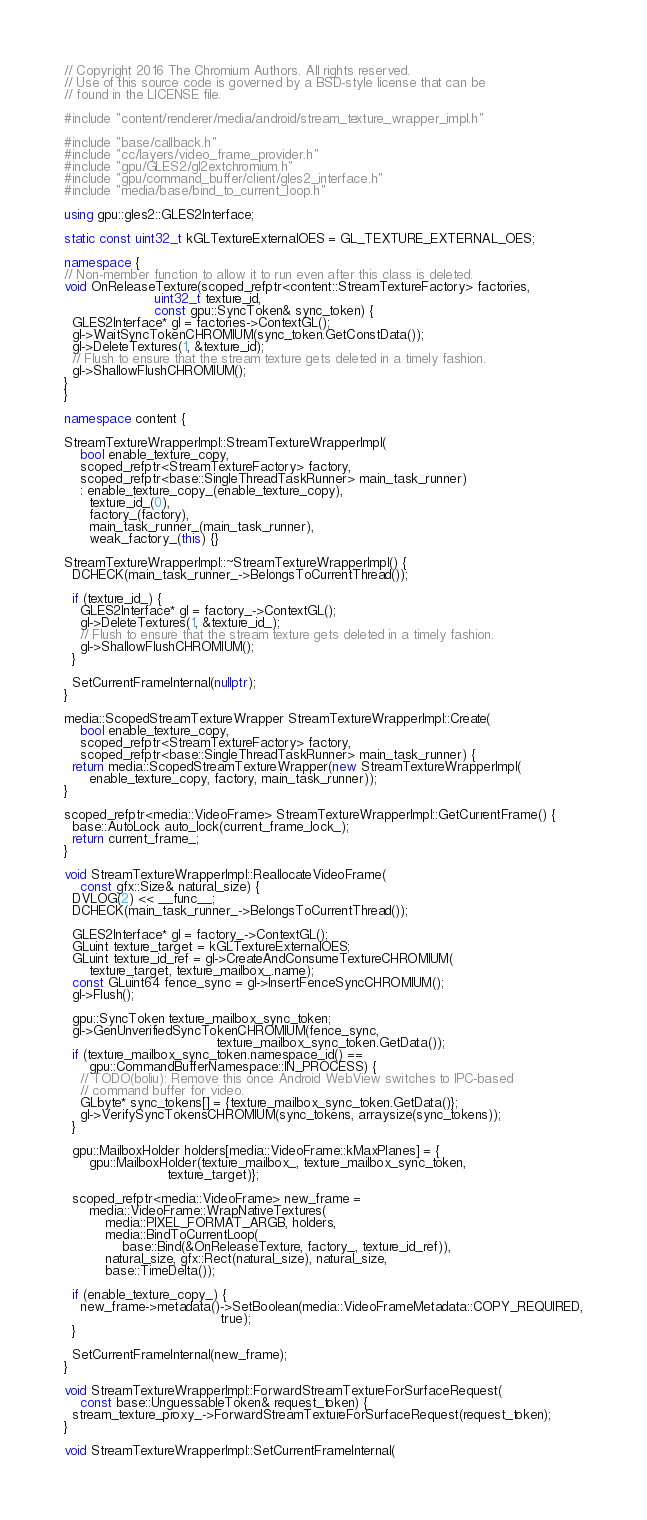Convert code to text. <code><loc_0><loc_0><loc_500><loc_500><_C++_>// Copyright 2016 The Chromium Authors. All rights reserved.
// Use of this source code is governed by a BSD-style license that can be
// found in the LICENSE file.

#include "content/renderer/media/android/stream_texture_wrapper_impl.h"

#include "base/callback.h"
#include "cc/layers/video_frame_provider.h"
#include "gpu/GLES2/gl2extchromium.h"
#include "gpu/command_buffer/client/gles2_interface.h"
#include "media/base/bind_to_current_loop.h"

using gpu::gles2::GLES2Interface;

static const uint32_t kGLTextureExternalOES = GL_TEXTURE_EXTERNAL_OES;

namespace {
// Non-member function to allow it to run even after this class is deleted.
void OnReleaseTexture(scoped_refptr<content::StreamTextureFactory> factories,
                      uint32_t texture_id,
                      const gpu::SyncToken& sync_token) {
  GLES2Interface* gl = factories->ContextGL();
  gl->WaitSyncTokenCHROMIUM(sync_token.GetConstData());
  gl->DeleteTextures(1, &texture_id);
  // Flush to ensure that the stream texture gets deleted in a timely fashion.
  gl->ShallowFlushCHROMIUM();
}
}

namespace content {

StreamTextureWrapperImpl::StreamTextureWrapperImpl(
    bool enable_texture_copy,
    scoped_refptr<StreamTextureFactory> factory,
    scoped_refptr<base::SingleThreadTaskRunner> main_task_runner)
    : enable_texture_copy_(enable_texture_copy),
      texture_id_(0),
      factory_(factory),
      main_task_runner_(main_task_runner),
      weak_factory_(this) {}

StreamTextureWrapperImpl::~StreamTextureWrapperImpl() {
  DCHECK(main_task_runner_->BelongsToCurrentThread());

  if (texture_id_) {
    GLES2Interface* gl = factory_->ContextGL();
    gl->DeleteTextures(1, &texture_id_);
    // Flush to ensure that the stream texture gets deleted in a timely fashion.
    gl->ShallowFlushCHROMIUM();
  }

  SetCurrentFrameInternal(nullptr);
}

media::ScopedStreamTextureWrapper StreamTextureWrapperImpl::Create(
    bool enable_texture_copy,
    scoped_refptr<StreamTextureFactory> factory,
    scoped_refptr<base::SingleThreadTaskRunner> main_task_runner) {
  return media::ScopedStreamTextureWrapper(new StreamTextureWrapperImpl(
      enable_texture_copy, factory, main_task_runner));
}

scoped_refptr<media::VideoFrame> StreamTextureWrapperImpl::GetCurrentFrame() {
  base::AutoLock auto_lock(current_frame_lock_);
  return current_frame_;
}

void StreamTextureWrapperImpl::ReallocateVideoFrame(
    const gfx::Size& natural_size) {
  DVLOG(2) << __func__;
  DCHECK(main_task_runner_->BelongsToCurrentThread());

  GLES2Interface* gl = factory_->ContextGL();
  GLuint texture_target = kGLTextureExternalOES;
  GLuint texture_id_ref = gl->CreateAndConsumeTextureCHROMIUM(
      texture_target, texture_mailbox_.name);
  const GLuint64 fence_sync = gl->InsertFenceSyncCHROMIUM();
  gl->Flush();

  gpu::SyncToken texture_mailbox_sync_token;
  gl->GenUnverifiedSyncTokenCHROMIUM(fence_sync,
                                     texture_mailbox_sync_token.GetData());
  if (texture_mailbox_sync_token.namespace_id() ==
      gpu::CommandBufferNamespace::IN_PROCESS) {
    // TODO(boliu): Remove this once Android WebView switches to IPC-based
    // command buffer for video.
    GLbyte* sync_tokens[] = {texture_mailbox_sync_token.GetData()};
    gl->VerifySyncTokensCHROMIUM(sync_tokens, arraysize(sync_tokens));
  }

  gpu::MailboxHolder holders[media::VideoFrame::kMaxPlanes] = {
      gpu::MailboxHolder(texture_mailbox_, texture_mailbox_sync_token,
                         texture_target)};

  scoped_refptr<media::VideoFrame> new_frame =
      media::VideoFrame::WrapNativeTextures(
          media::PIXEL_FORMAT_ARGB, holders,
          media::BindToCurrentLoop(
              base::Bind(&OnReleaseTexture, factory_, texture_id_ref)),
          natural_size, gfx::Rect(natural_size), natural_size,
          base::TimeDelta());

  if (enable_texture_copy_) {
    new_frame->metadata()->SetBoolean(media::VideoFrameMetadata::COPY_REQUIRED,
                                      true);
  }

  SetCurrentFrameInternal(new_frame);
}

void StreamTextureWrapperImpl::ForwardStreamTextureForSurfaceRequest(
    const base::UnguessableToken& request_token) {
  stream_texture_proxy_->ForwardStreamTextureForSurfaceRequest(request_token);
}

void StreamTextureWrapperImpl::SetCurrentFrameInternal(</code> 